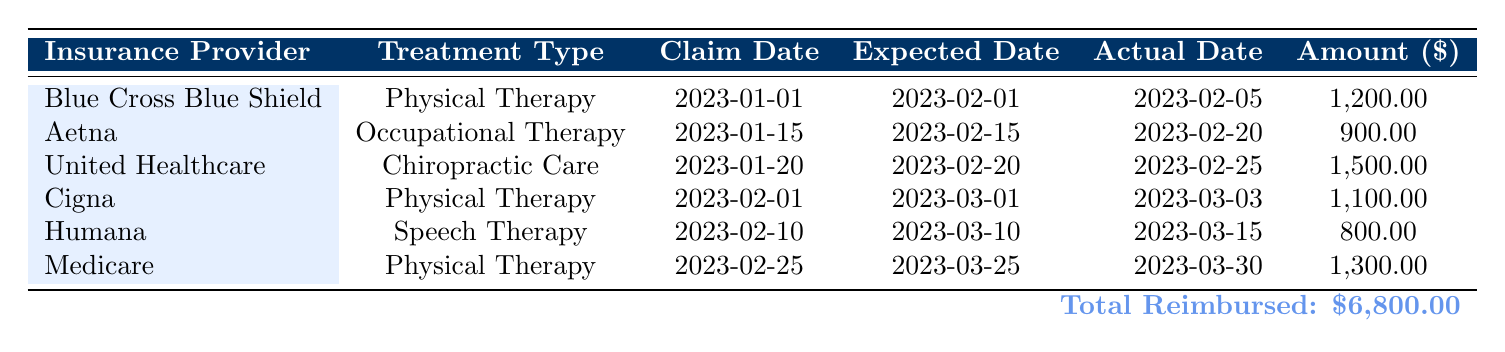What is the amount reimbursed by Aetna? According to the table, under the Aetna row, the amount reimbursed for occupational therapy is given as 900.00.
Answer: 900.00 What was the expected reimbursement date for Medicare's physical therapy claim? The Medicare row indicates that the expected reimbursement date for the physical therapy claim was 2023-03-25.
Answer: 2023-03-25 How many days did it take for United Healthcare to reimburse after the expected date? The expected reimbursement date for United Healthcare was 2023-02-20, and the actual reimbursement date was 2023-02-25. The difference is 5 days (25 - 20).
Answer: 5 days Is the claim status for Cigna's physical therapy claim marked as complete? The Cigna row shows that the claim status is listed as "Complete." Therefore, this statement is true.
Answer: Yes What is the total amount reimbursed for all therapy types listed? The total amount can be calculated by summing all the amounts in the "Amount" column: 1200.00 + 900.00 + 1500.00 + 1100.00 + 800.00 + 1300.00 = 6800.00.
Answer: 6800.00 Which insurance provider took the longest time to reimburse, based on the actual date? Comparing the actual reimbursement dates: Blue Cross Blue Shield on 2023-02-05, Aetna on 2023-02-20, United Healthcare on 2023-02-25, Cigna on 2023-03-03, Humana on 2023-03-15, and Medicare on 2023-03-30, we see that Medicare took the longest to reimburse, with its actual date being the latest.
Answer: Medicare Which treatment type had the highest amount reimbursed? From the table, the treatment type with the highest reimbursement is Chiropractic Care under United Healthcare, which totals 1500.00.
Answer: Chiropractic Care How many days late was Humana in processing the reimbursement compared to the expected date? The expected reimbursement date for Humana is 2023-03-10, while the actual reimbursement date is 2023-03-15. The difference is 5 days late (15 - 10).
Answer: 5 days Did all claims submitted listed in the table ended with a status other than pending? Every row in the table shows the claim status as "Complete," indicating that none of the claims are pending. Thus, the answer to this question is true.
Answer: Yes 